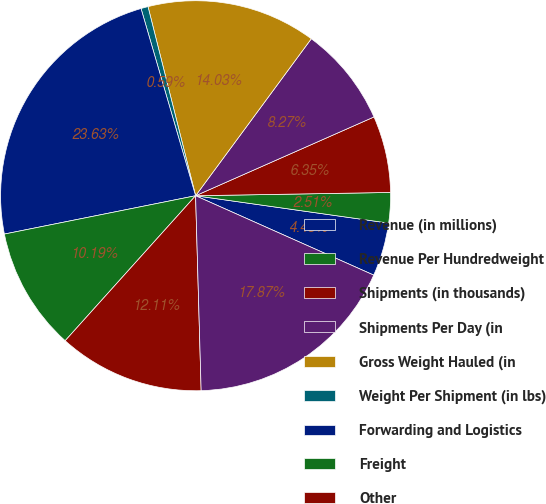<chart> <loc_0><loc_0><loc_500><loc_500><pie_chart><fcel>Revenue (in millions)<fcel>Revenue Per Hundredweight<fcel>Shipments (in thousands)<fcel>Shipments Per Day (in<fcel>Gross Weight Hauled (in<fcel>Weight Per Shipment (in lbs)<fcel>Forwarding and Logistics<fcel>Freight<fcel>Other<fcel>Total Revenue<nl><fcel>4.43%<fcel>2.51%<fcel>6.35%<fcel>8.27%<fcel>14.03%<fcel>0.59%<fcel>23.63%<fcel>10.19%<fcel>12.11%<fcel>17.87%<nl></chart> 